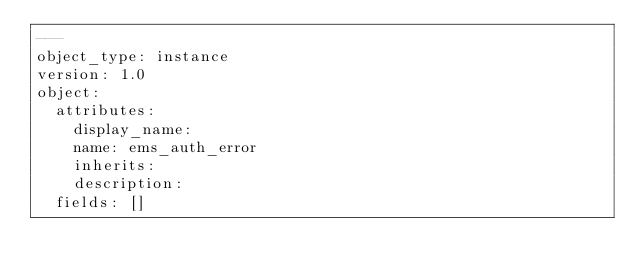Convert code to text. <code><loc_0><loc_0><loc_500><loc_500><_YAML_>---
object_type: instance
version: 1.0
object:
  attributes:
    display_name: 
    name: ems_auth_error
    inherits: 
    description: 
  fields: []
</code> 